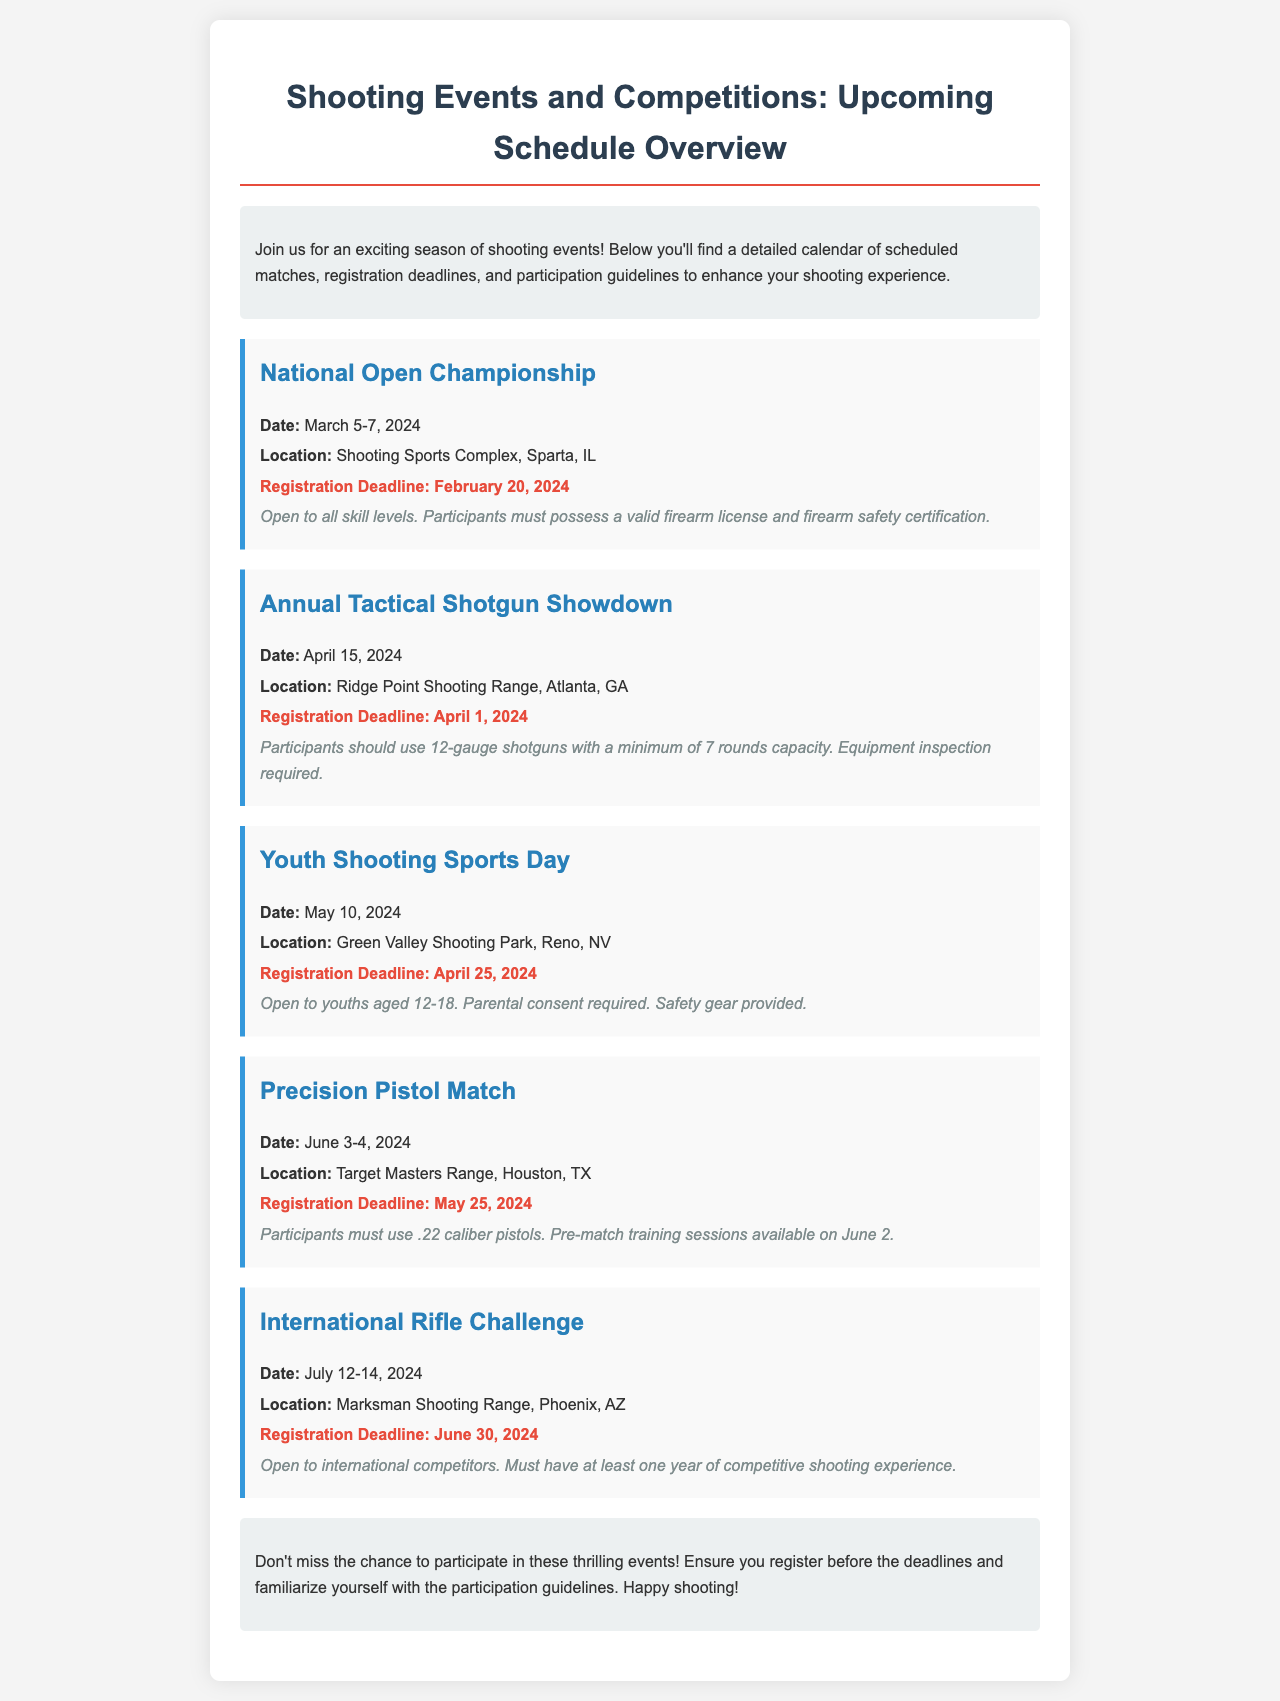What is the date of the National Open Championship? The date is specified in the event details, which states March 5-7, 2024.
Answer: March 5-7, 2024 Where is the Youth Shooting Sports Day being held? The location is mentioned in the event details as Green Valley Shooting Park, Reno, NV.
Answer: Green Valley Shooting Park, Reno, NV What is the registration deadline for the Precision Pistol Match? The registration deadline for this event is provided in the details and is May 25, 2024.
Answer: May 25, 2024 Who can participate in the Annual Tactical Shotgun Showdown? The guidelines state that participants should use 12-gauge shotguns and meet certain equipment regulations.
Answer: 12-gauge shotguns What is required for youths participating in the Youth Shooting Sports Day? The guidelines indicate that parental consent is required for youths aged 12-18.
Answer: Parental consent How many events are scheduled in July 2024? The document mentions one event in July, which is the International Rifle Challenge.
Answer: One event What type of firearm is required for the Precision Pistol Match? The guidelines specify that participants must use .22 caliber pistols.
Answer: .22 caliber pistols What is the maximum age for participants in the Youth Shooting Sports Day? The age range is stated in the guidelines, which mentions 12-18 years.
Answer: 18 years Is pre-match training available for participants in the Precision Pistol Match? The details mention that pre-match training sessions are available on June 2.
Answer: Yes 